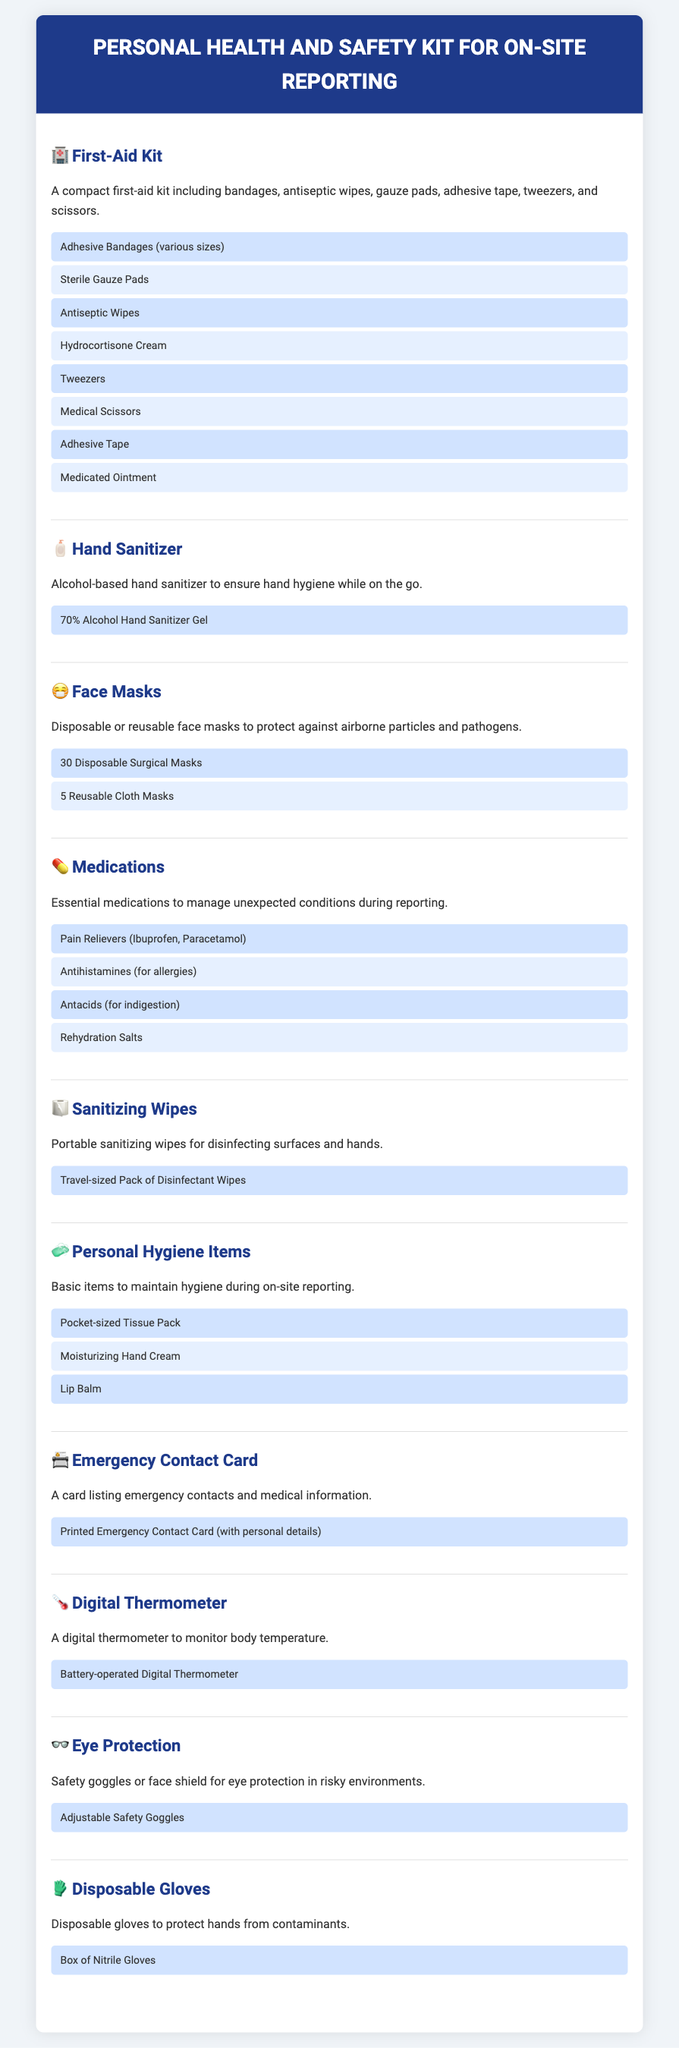What items are included in the first-aid kit? The first-aid kit includes various medical supplies such as bandages, antiseptic wipes, gauze pads, and more as detailed in the document.
Answer: Adhesive Bandages, Sterile Gauze Pads, Antiseptic Wipes, Hydrocortisone Cream, Tweezers, Medical Scissors, Adhesive Tape, Medicated Ointment How many disposable surgical masks are listed? The document states the number of disposable surgical masks included in the kit.
Answer: 30 Disposable Surgical Masks What is the purpose of the emergency contact card? The emergency contact card provides information on emergency contacts and medical details for quick access during unforeseen events.
Answer: A card listing emergency contacts and medical information Which item is recommended for hand hygiene? The document specifies a particular item in the kit that is intended for maintaining hand hygiene.
Answer: Alcohol-based hand sanitizer What type of gloves are in the personal health and safety kit? The kit lists a specific type of gloves that are included for hand protection.
Answer: Nitrile Gloves What equipment is provided for monitoring body temperature? A specific item for checking body temperature is mentioned in the document.
Answer: Digital Thermometer Why is eye protection included in the kit? The document explains the inclusion of eye protection to ensure safety in risky environments while reporting on-site.
Answer: For eye protection in risky environments How many reusable cloth masks are available in the kit? The number of reusable cloth masks included in the kit is clearly mentioned in the document.
Answer: 5 Reusable Cloth Masks What should be used for disinfecting surfaces? The document includes a specific item meant for disinfecting surfaces while on-site.
Answer: Travel-sized Pack of Disinfectant Wipes 